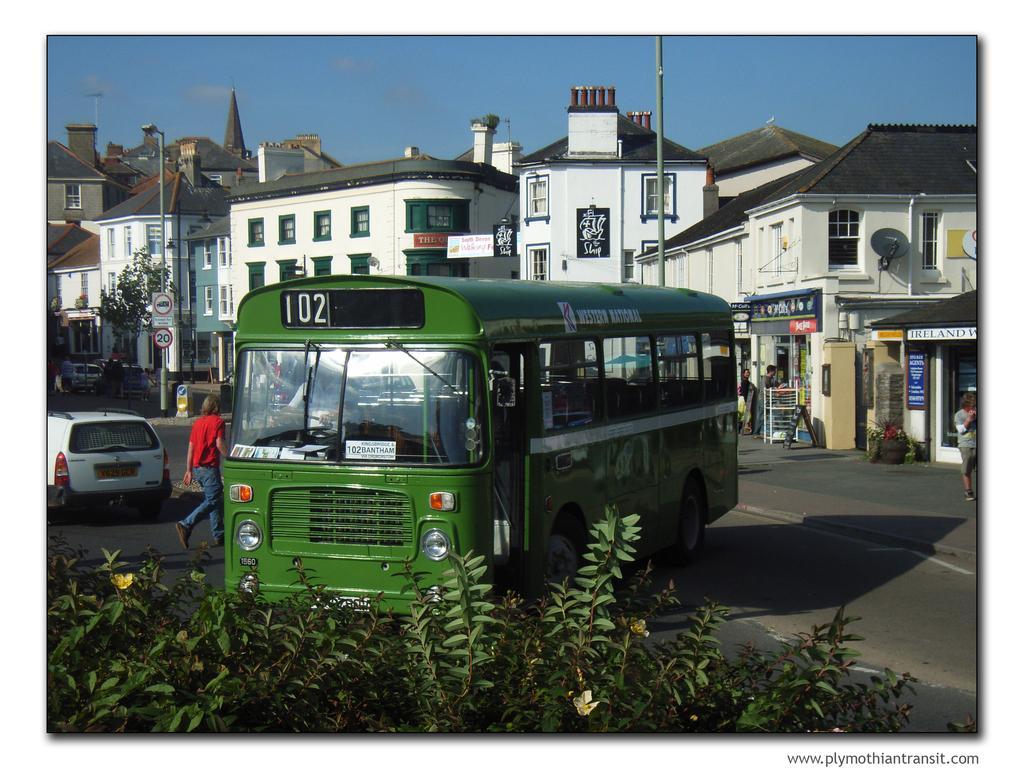Could you give a brief overview of what you see in this image? In the picture we can see a bus on the road which is green in color and in front of it we can see some plants with flowers and beside to it we can see a man walking and a car which is white in color and in the background we can see a buildings, shops, poles, street lights and sky. 